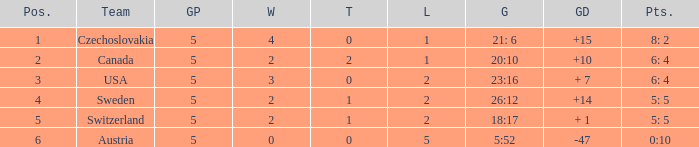What was the largest tie when the G.P was more than 5? None. 